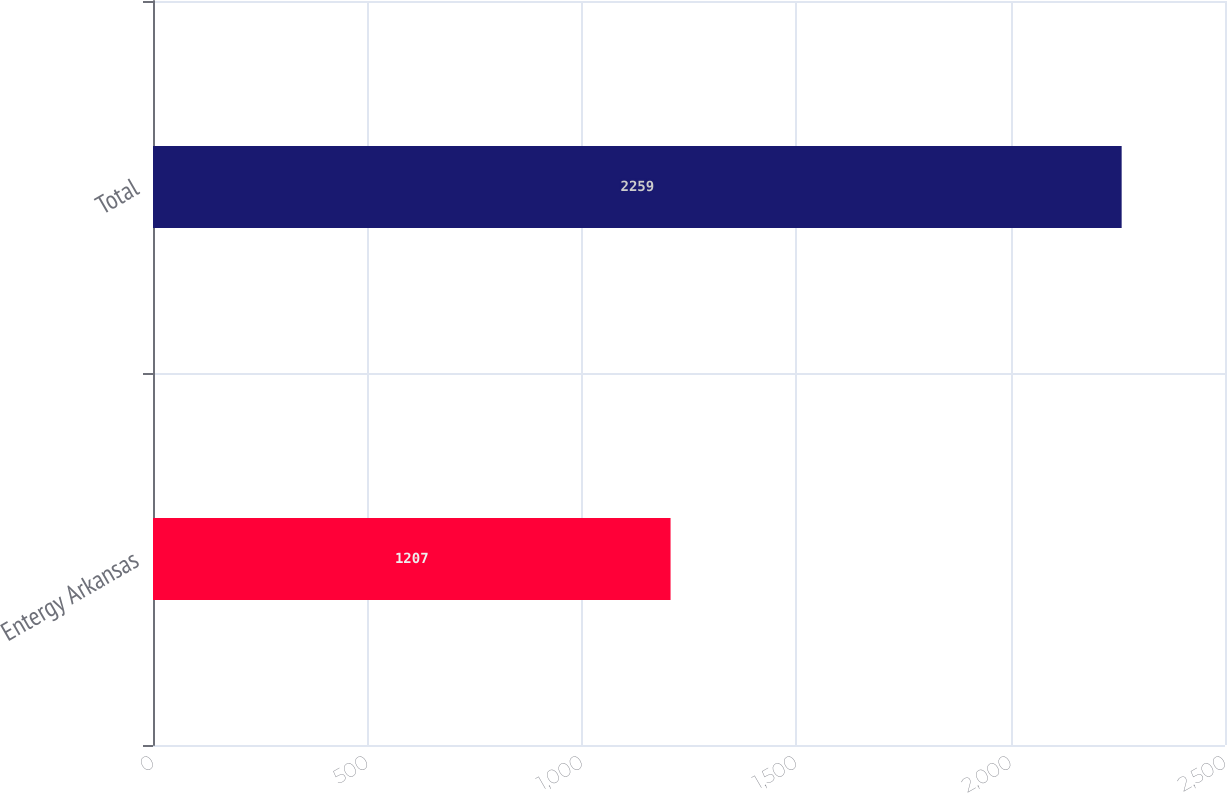Convert chart to OTSL. <chart><loc_0><loc_0><loc_500><loc_500><bar_chart><fcel>Entergy Arkansas<fcel>Total<nl><fcel>1207<fcel>2259<nl></chart> 